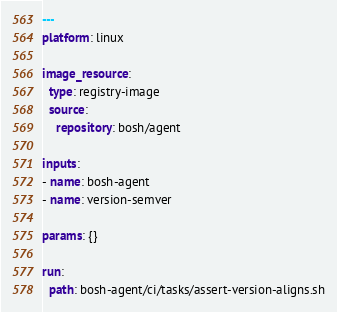Convert code to text. <code><loc_0><loc_0><loc_500><loc_500><_YAML_>---
platform: linux

image_resource:
  type: registry-image
  source:
    repository: bosh/agent

inputs:
- name: bosh-agent
- name: version-semver

params: {}

run:
  path: bosh-agent/ci/tasks/assert-version-aligns.sh
</code> 